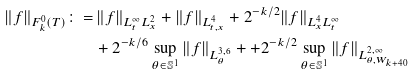Convert formula to latex. <formula><loc_0><loc_0><loc_500><loc_500>\| f \| _ { F _ { k } ^ { 0 } ( T ) } \colon = & \, \| f \| _ { L _ { t } ^ { \infty } L _ { x } ^ { 2 } } + \| f \| _ { L _ { t , x } ^ { 4 } } + 2 ^ { - k / 2 } \| f \| _ { L _ { x } ^ { 4 } L _ { t } ^ { \infty } } \\ & + 2 ^ { - k / 6 } \sup _ { \theta \in \mathbb { S } ^ { 1 } } \| f \| _ { L ^ { 3 , 6 } _ { \theta } } + + 2 ^ { - k / 2 } \sup _ { \theta \in \mathbb { S } ^ { 1 } } \| f \| _ { L _ { \theta , W _ { k + 4 0 } } ^ { 2 , \infty } }</formula> 